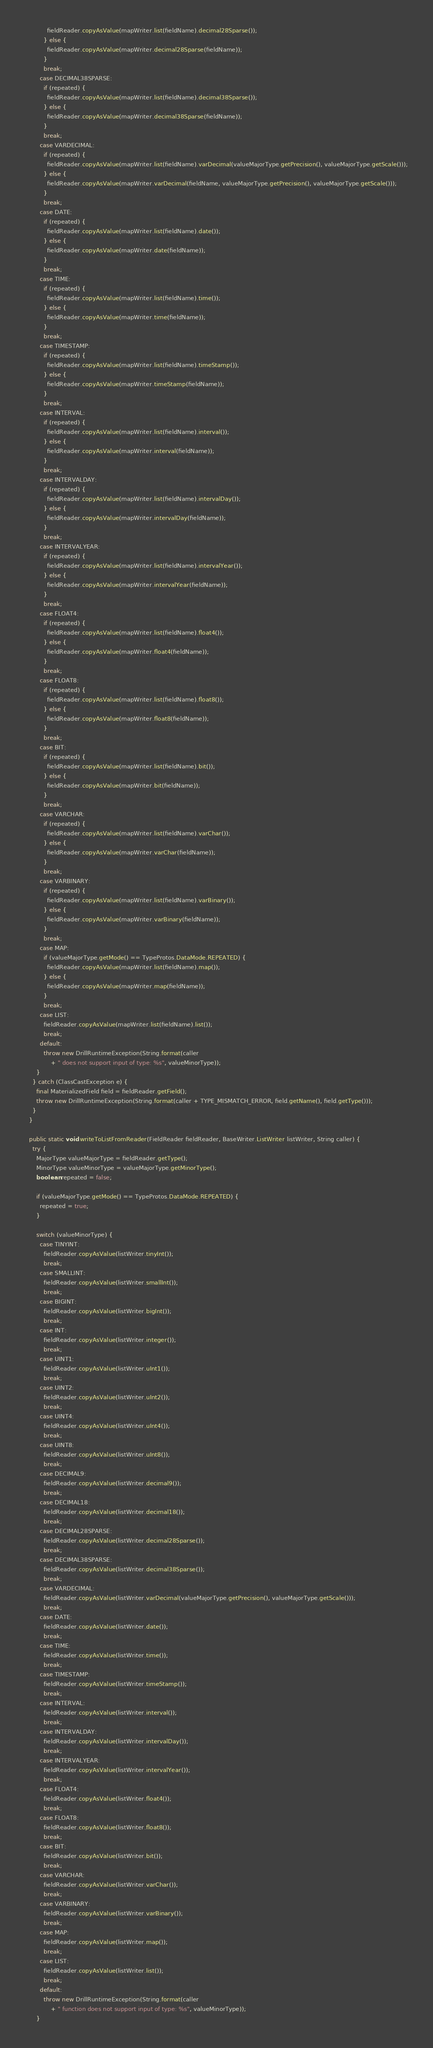Convert code to text. <code><loc_0><loc_0><loc_500><loc_500><_Java_>            fieldReader.copyAsValue(mapWriter.list(fieldName).decimal28Sparse());
          } else {
            fieldReader.copyAsValue(mapWriter.decimal28Sparse(fieldName));
          }
          break;
        case DECIMAL38SPARSE:
          if (repeated) {
            fieldReader.copyAsValue(mapWriter.list(fieldName).decimal38Sparse());
          } else {
            fieldReader.copyAsValue(mapWriter.decimal38Sparse(fieldName));
          }
          break;
        case VARDECIMAL:
          if (repeated) {
            fieldReader.copyAsValue(mapWriter.list(fieldName).varDecimal(valueMajorType.getPrecision(), valueMajorType.getScale()));
          } else {
            fieldReader.copyAsValue(mapWriter.varDecimal(fieldName, valueMajorType.getPrecision(), valueMajorType.getScale()));
          }
          break;
        case DATE:
          if (repeated) {
            fieldReader.copyAsValue(mapWriter.list(fieldName).date());
          } else {
            fieldReader.copyAsValue(mapWriter.date(fieldName));
          }
          break;
        case TIME:
          if (repeated) {
            fieldReader.copyAsValue(mapWriter.list(fieldName).time());
          } else {
            fieldReader.copyAsValue(mapWriter.time(fieldName));
          }
          break;
        case TIMESTAMP:
          if (repeated) {
            fieldReader.copyAsValue(mapWriter.list(fieldName).timeStamp());
          } else {
            fieldReader.copyAsValue(mapWriter.timeStamp(fieldName));
          }
          break;
        case INTERVAL:
          if (repeated) {
            fieldReader.copyAsValue(mapWriter.list(fieldName).interval());
          } else {
            fieldReader.copyAsValue(mapWriter.interval(fieldName));
          }
          break;
        case INTERVALDAY:
          if (repeated) {
            fieldReader.copyAsValue(mapWriter.list(fieldName).intervalDay());
          } else {
            fieldReader.copyAsValue(mapWriter.intervalDay(fieldName));
          }
          break;
        case INTERVALYEAR:
          if (repeated) {
            fieldReader.copyAsValue(mapWriter.list(fieldName).intervalYear());
          } else {
            fieldReader.copyAsValue(mapWriter.intervalYear(fieldName));
          }
          break;
        case FLOAT4:
          if (repeated) {
            fieldReader.copyAsValue(mapWriter.list(fieldName).float4());
          } else {
            fieldReader.copyAsValue(mapWriter.float4(fieldName));
          }
          break;
        case FLOAT8:
          if (repeated) {
            fieldReader.copyAsValue(mapWriter.list(fieldName).float8());
          } else {
            fieldReader.copyAsValue(mapWriter.float8(fieldName));
          }
          break;
        case BIT:
          if (repeated) {
            fieldReader.copyAsValue(mapWriter.list(fieldName).bit());
          } else {
            fieldReader.copyAsValue(mapWriter.bit(fieldName));
          }
          break;
        case VARCHAR:
          if (repeated) {
            fieldReader.copyAsValue(mapWriter.list(fieldName).varChar());
          } else {
            fieldReader.copyAsValue(mapWriter.varChar(fieldName));
          }
          break;
        case VARBINARY:
          if (repeated) {
            fieldReader.copyAsValue(mapWriter.list(fieldName).varBinary());
          } else {
            fieldReader.copyAsValue(mapWriter.varBinary(fieldName));
          }
          break;
        case MAP:
          if (valueMajorType.getMode() == TypeProtos.DataMode.REPEATED) {
            fieldReader.copyAsValue(mapWriter.list(fieldName).map());
          } else {
            fieldReader.copyAsValue(mapWriter.map(fieldName));
          }
          break;
        case LIST:
          fieldReader.copyAsValue(mapWriter.list(fieldName).list());
          break;
        default:
          throw new DrillRuntimeException(String.format(caller
              + " does not support input of type: %s", valueMinorType));
      }
    } catch (ClassCastException e) {
      final MaterializedField field = fieldReader.getField();
      throw new DrillRuntimeException(String.format(caller + TYPE_MISMATCH_ERROR, field.getName(), field.getType()));
    }
  }

  public static void writeToListFromReader(FieldReader fieldReader, BaseWriter.ListWriter listWriter, String caller) {
    try {
      MajorType valueMajorType = fieldReader.getType();
      MinorType valueMinorType = valueMajorType.getMinorType();
      boolean repeated = false;

      if (valueMajorType.getMode() == TypeProtos.DataMode.REPEATED) {
        repeated = true;
      }

      switch (valueMinorType) {
        case TINYINT:
          fieldReader.copyAsValue(listWriter.tinyInt());
          break;
        case SMALLINT:
          fieldReader.copyAsValue(listWriter.smallInt());
          break;
        case BIGINT:
          fieldReader.copyAsValue(listWriter.bigInt());
          break;
        case INT:
          fieldReader.copyAsValue(listWriter.integer());
          break;
        case UINT1:
          fieldReader.copyAsValue(listWriter.uInt1());
          break;
        case UINT2:
          fieldReader.copyAsValue(listWriter.uInt2());
          break;
        case UINT4:
          fieldReader.copyAsValue(listWriter.uInt4());
          break;
        case UINT8:
          fieldReader.copyAsValue(listWriter.uInt8());
          break;
        case DECIMAL9:
          fieldReader.copyAsValue(listWriter.decimal9());
          break;
        case DECIMAL18:
          fieldReader.copyAsValue(listWriter.decimal18());
          break;
        case DECIMAL28SPARSE:
          fieldReader.copyAsValue(listWriter.decimal28Sparse());
          break;
        case DECIMAL38SPARSE:
          fieldReader.copyAsValue(listWriter.decimal38Sparse());
          break;
        case VARDECIMAL:
          fieldReader.copyAsValue(listWriter.varDecimal(valueMajorType.getPrecision(), valueMajorType.getScale()));
          break;
        case DATE:
          fieldReader.copyAsValue(listWriter.date());
          break;
        case TIME:
          fieldReader.copyAsValue(listWriter.time());
          break;
        case TIMESTAMP:
          fieldReader.copyAsValue(listWriter.timeStamp());
          break;
        case INTERVAL:
          fieldReader.copyAsValue(listWriter.interval());
          break;
        case INTERVALDAY:
          fieldReader.copyAsValue(listWriter.intervalDay());
          break;
        case INTERVALYEAR:
          fieldReader.copyAsValue(listWriter.intervalYear());
          break;
        case FLOAT4:
          fieldReader.copyAsValue(listWriter.float4());
          break;
        case FLOAT8:
          fieldReader.copyAsValue(listWriter.float8());
          break;
        case BIT:
          fieldReader.copyAsValue(listWriter.bit());
          break;
        case VARCHAR:
          fieldReader.copyAsValue(listWriter.varChar());
          break;
        case VARBINARY:
          fieldReader.copyAsValue(listWriter.varBinary());
          break;
        case MAP:
          fieldReader.copyAsValue(listWriter.map());
          break;
        case LIST:
          fieldReader.copyAsValue(listWriter.list());
          break;
        default:
          throw new DrillRuntimeException(String.format(caller
              + " function does not support input of type: %s", valueMinorType));
      }</code> 